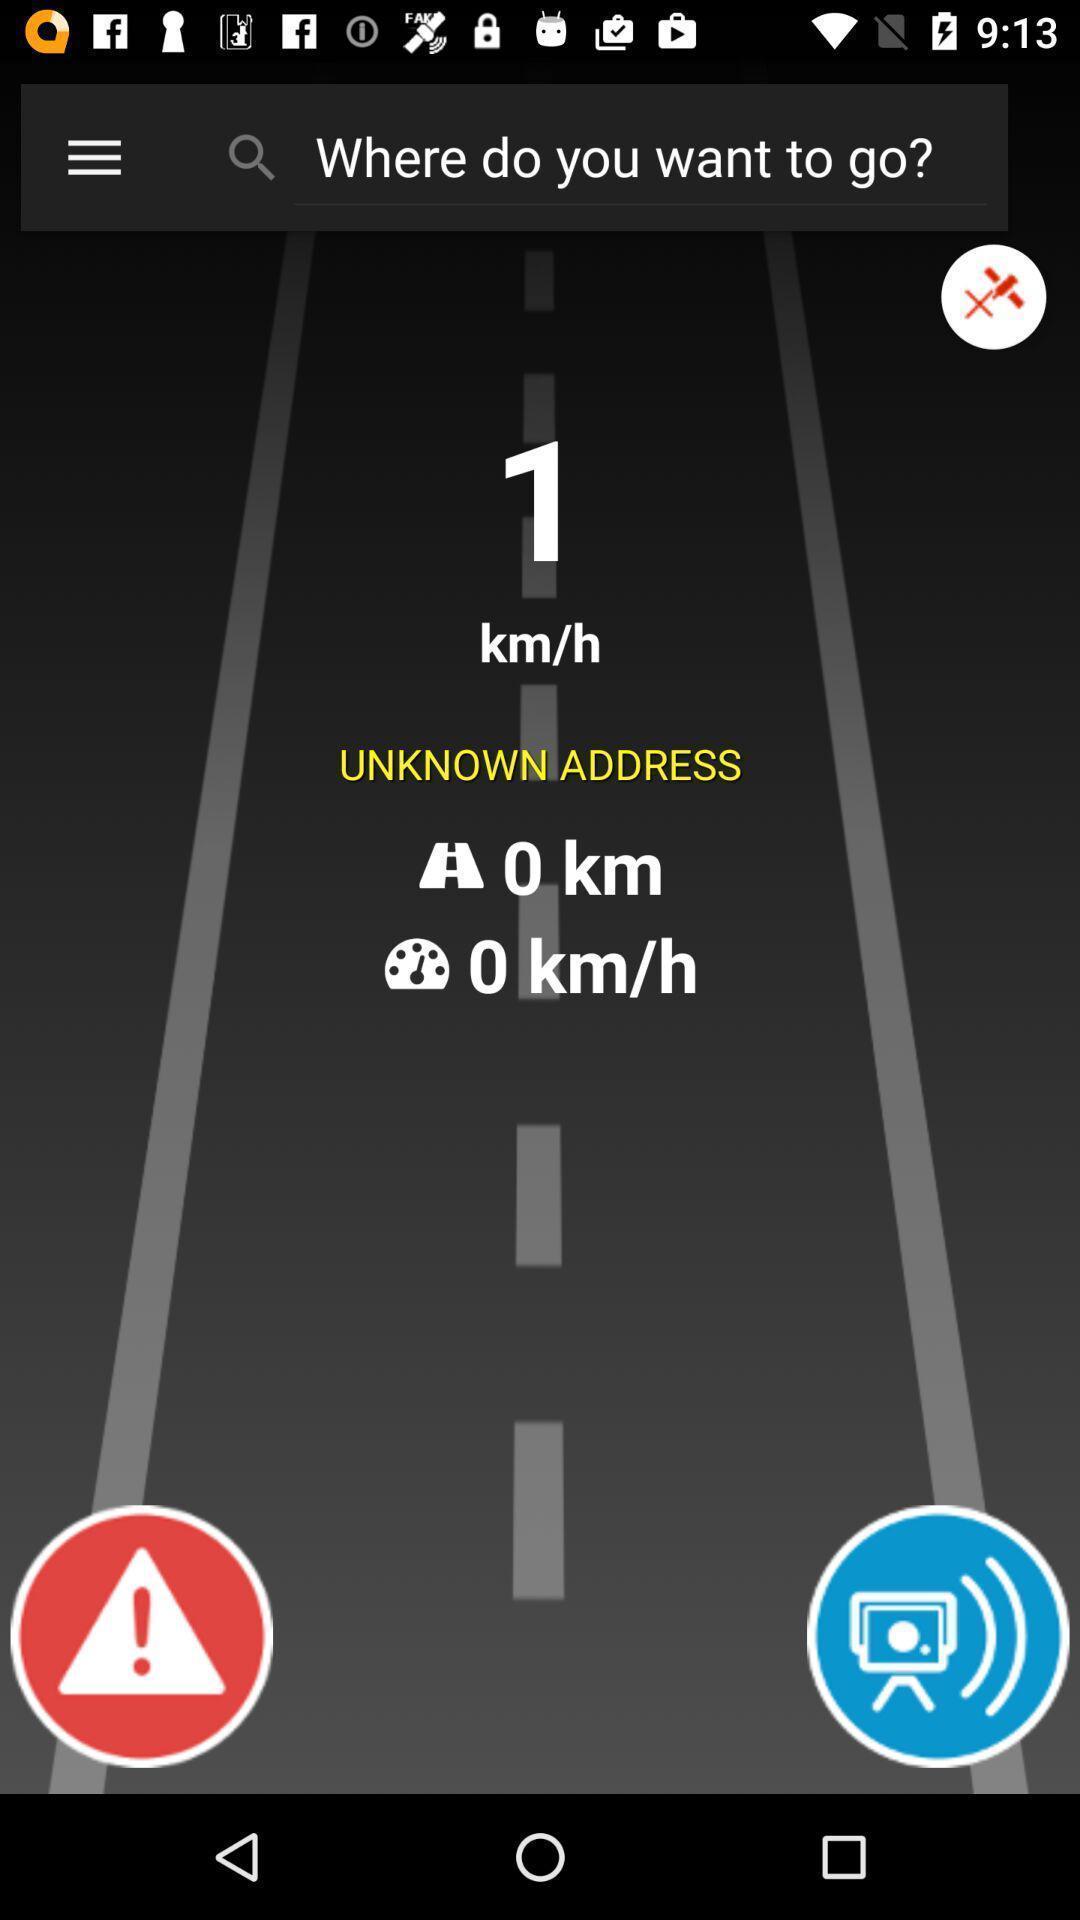Tell me about the visual elements in this screen capture. Search page for navigation and traffic time information. 